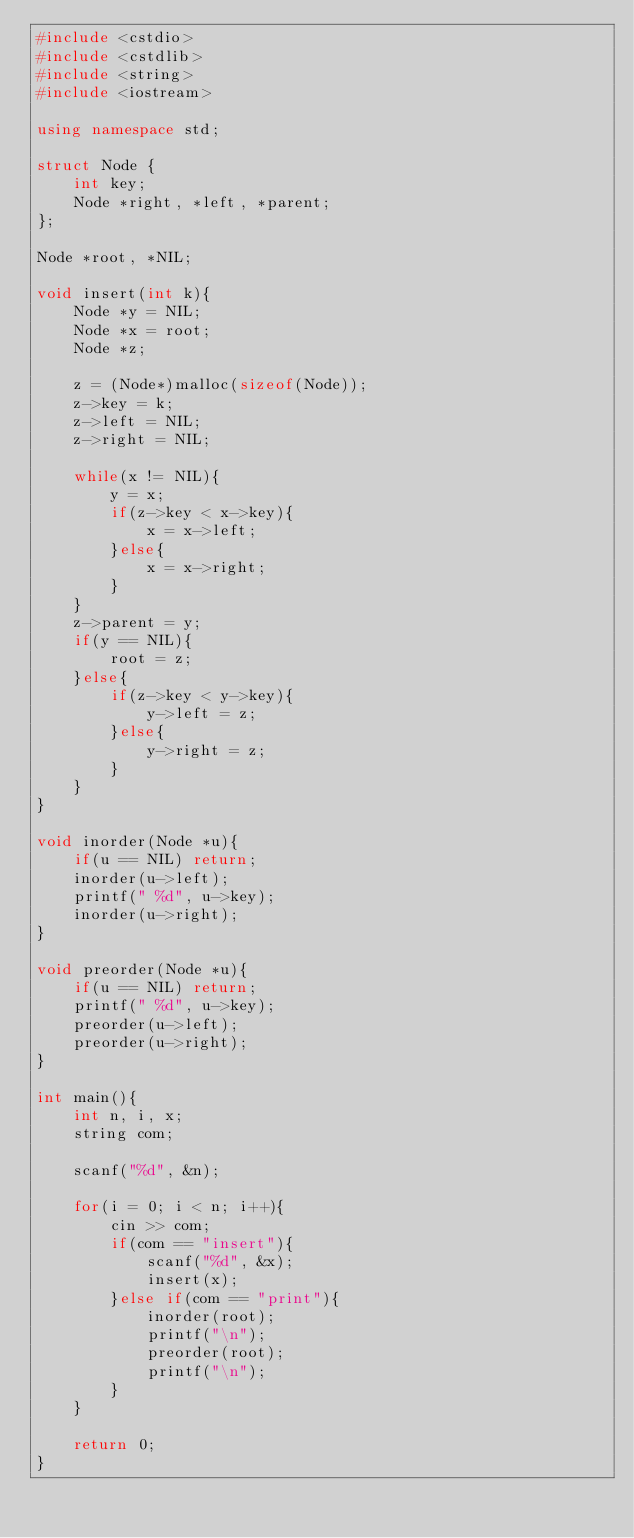Convert code to text. <code><loc_0><loc_0><loc_500><loc_500><_C++_>#include <cstdio>
#include <cstdlib>
#include <string>
#include <iostream>

using namespace std;

struct Node {
    int key;
    Node *right, *left, *parent;
};

Node *root, *NIL;

void insert(int k){
    Node *y = NIL;
    Node *x = root;
    Node *z;

    z = (Node*)malloc(sizeof(Node));
    z->key = k;
    z->left = NIL;
    z->right = NIL;

    while(x != NIL){
        y = x;
        if(z->key < x->key){
            x = x->left;
        }else{
            x = x->right;
        }
    }
    z->parent = y;
    if(y == NIL){
        root = z;
    }else{
        if(z->key < y->key){
            y->left = z;
        }else{
            y->right = z;
        }
    }
}

void inorder(Node *u){
    if(u == NIL) return;
    inorder(u->left);
    printf(" %d", u->key);
    inorder(u->right);
}

void preorder(Node *u){
    if(u == NIL) return;
    printf(" %d", u->key);
    preorder(u->left);
    preorder(u->right);
}

int main(){
    int n, i, x;
    string com;

    scanf("%d", &n);

    for(i = 0; i < n; i++){
        cin >> com;
        if(com == "insert"){
            scanf("%d", &x);
            insert(x);
        }else if(com == "print"){
            inorder(root);
            printf("\n");
            preorder(root);
            printf("\n");
        }
    }

    return 0;
}

</code> 